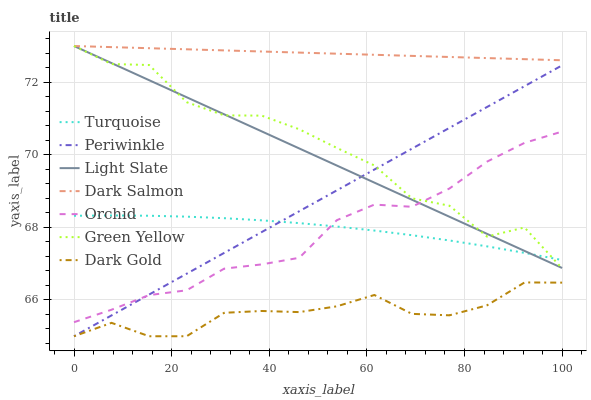Does Dark Gold have the minimum area under the curve?
Answer yes or no. Yes. Does Dark Salmon have the maximum area under the curve?
Answer yes or no. Yes. Does Light Slate have the minimum area under the curve?
Answer yes or no. No. Does Light Slate have the maximum area under the curve?
Answer yes or no. No. Is Dark Salmon the smoothest?
Answer yes or no. Yes. Is Green Yellow the roughest?
Answer yes or no. Yes. Is Dark Gold the smoothest?
Answer yes or no. No. Is Dark Gold the roughest?
Answer yes or no. No. Does Light Slate have the lowest value?
Answer yes or no. No. Does Green Yellow have the highest value?
Answer yes or no. Yes. Does Dark Gold have the highest value?
Answer yes or no. No. Is Dark Gold less than Green Yellow?
Answer yes or no. Yes. Is Dark Salmon greater than Dark Gold?
Answer yes or no. Yes. Does Dark Salmon intersect Green Yellow?
Answer yes or no. Yes. Is Dark Salmon less than Green Yellow?
Answer yes or no. No. Is Dark Salmon greater than Green Yellow?
Answer yes or no. No. Does Dark Gold intersect Green Yellow?
Answer yes or no. No. 